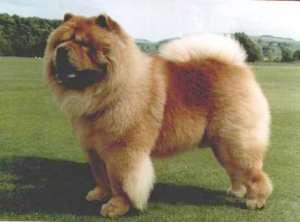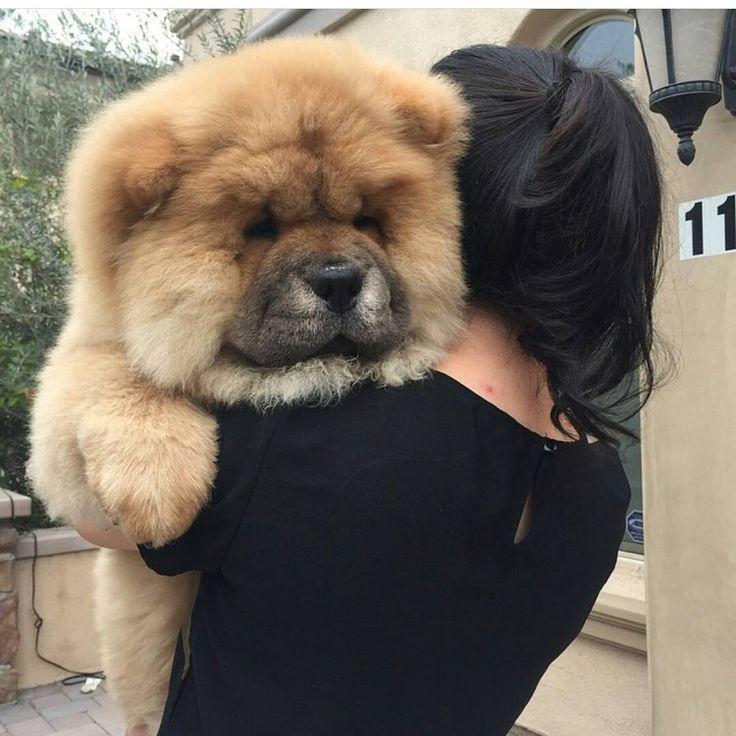The first image is the image on the left, the second image is the image on the right. Considering the images on both sides, is "Two dogs are standing on the grass" valid? Answer yes or no. No. 